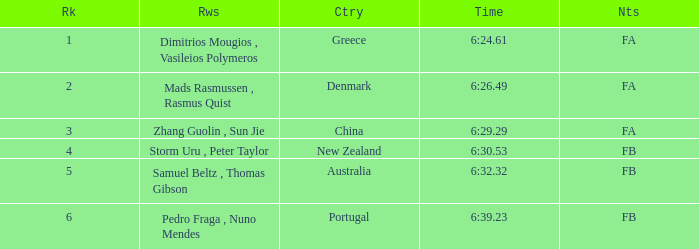What is the names of the rowers that the time was 6:24.61? Dimitrios Mougios , Vasileios Polymeros. 